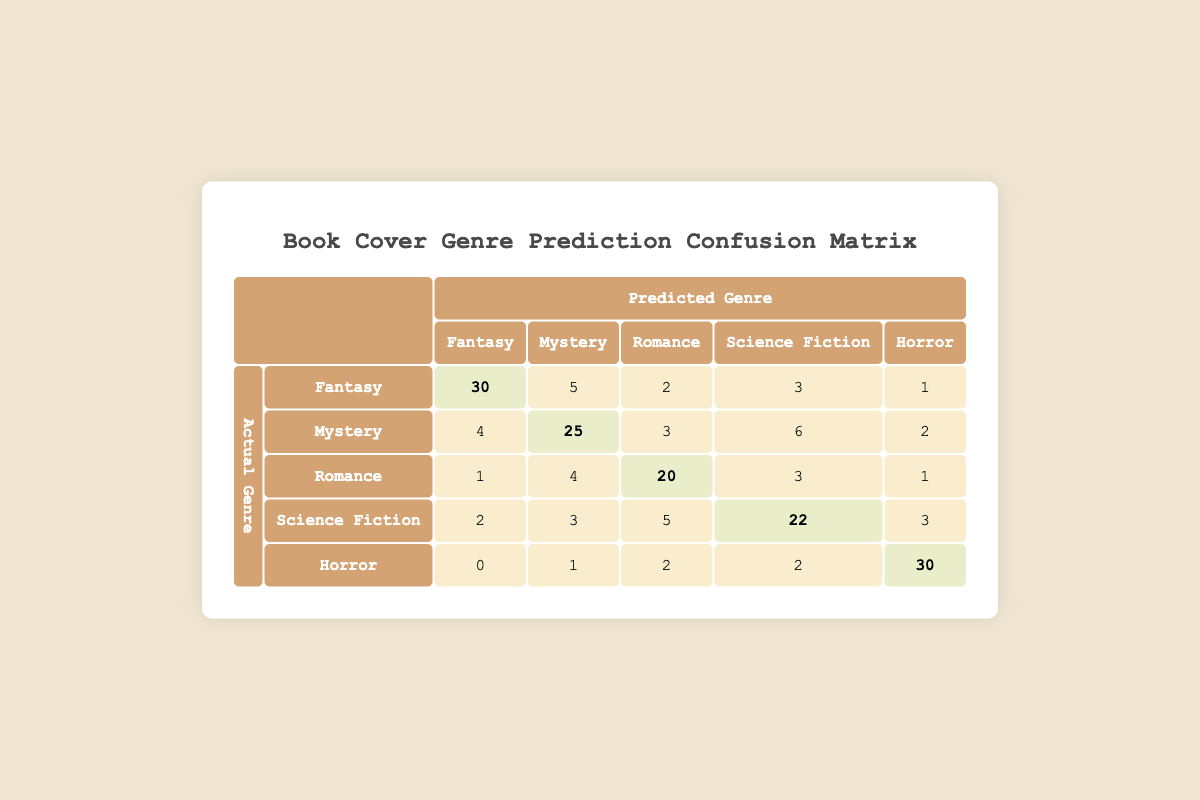What is the highest number of predictions for any genre? The highest number in the table is 30, found in the Fantasy genre's predicted genre column as the count for actual Fantasy.
Answer: 30 How many actual Romance book covers were predicted as Science Fiction? Looking at the Romance row under the Science Fiction column, the value is 3, which represents the count of actual Romance covers predicted as Science Fiction.
Answer: 3 What is the total number of predictions made for the Horror genre? To find the total predictions for the Horror genre, sum the values in the Horror column: 0 + 1 + 2 + 2 + 30 = 35.
Answer: 35 Is the prediction model more accurate for Fantasy or Mystery? The accuracy is determined by the diagonal elements (true positives) for Fantasy (30) and Mystery (25). Since 30 is greater than 25, the model is more accurate for Fantasy.
Answer: Yes How many actual Science Fiction book covers were predicted correctly? The number of correctly predicted Science Fiction covers is found in the intersection where actual and predicted are both Science Fiction. This value is 22.
Answer: 22 What percentage of actual Horror covers were predicted correctly? There are 30 actual Horror covers predicted as Horror. To find the percentage correct: (30 / (0 + 1 + 2 + 2 + 30)) * 100 = (30 / 35) * 100 ≈ 85.71%.
Answer: 85.71% What is the total number of misclassified predictions for the Romance genre? Adding the values in the Romance row excluding the correctly predicted Romance count provides the misclassifications: 1 + 4 + 3 + 1 = 9.
Answer: 9 Which genre had the fewest predictions overall? Summing the predictions for each genre reveals the counts: Fantasy (41), Mystery (40), Romance (29), Science Fiction (35), and Horror (35). Romance has the fewest at 29.
Answer: Romance 